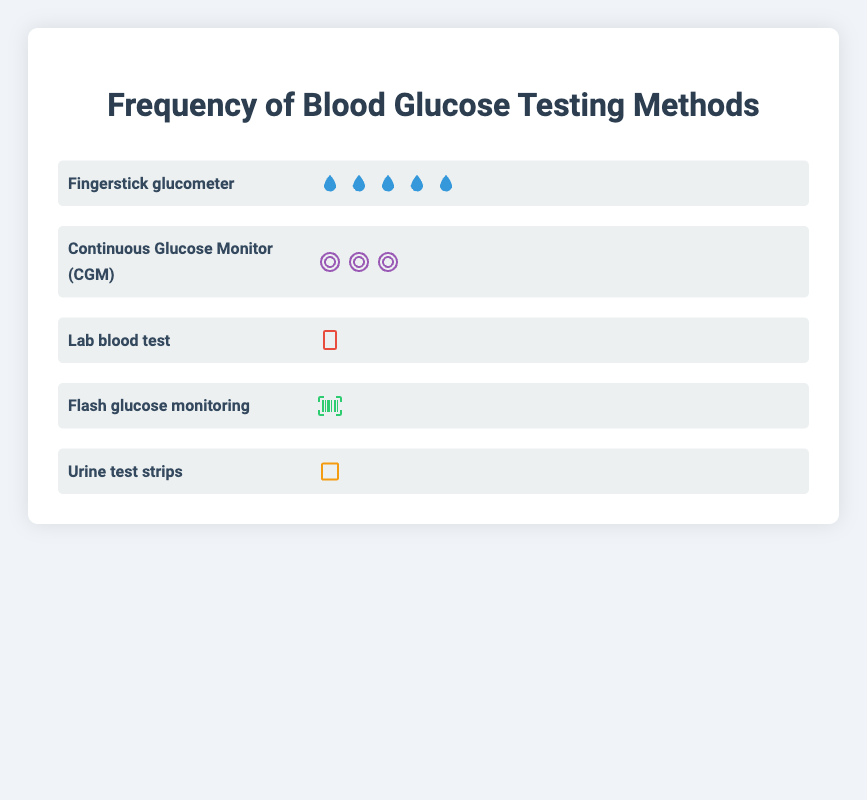What's the most frequently used blood glucose testing method? The "Fingerstick glucometer" method has the most icons (5), indicating it is the most commonly used method.
Answer: Fingerstick glucometer Which testing method is used the least frequently? The "Urine test strips" method has only one icon, indicating it is the least commonly used method.
Answer: Urine test strips How many more people use the Fingerstick glucometer compared to the Continuous Glucose Monitor (CGM)? The Fingerstick glucometer has 5 icons, while the CGM has 3 icons. The difference is 5 - 3 = 2.
Answer: 2 What percentage of people use Flash glucose monitoring? Flash glucose monitoring has 1 icon out of the total of 12 icons shown in the plot. The percentage is (1/12) * 100 ≈ 8.3%.
Answer: 8.3% Which testing methods have more than one icon? Methods with more than one icon are "Fingerstick glucometer" (5 icons), and "Continuous Glucose Monitor (CGM)" (3 icons).
Answer: Fingerstick glucometer, Continuous Glucose Monitor (CGM) How does the use of Lab blood tests compare to Flash glucose monitoring? Both Lab blood tests and Flash glucose monitoring each have 1 icon, indicating they are equally used.
Answer: Equal What's the combined frequency of Fingerstick glucometer and Continuous Glucose Monitor (CGM)? Fingerstick glucometer has 5 icons and CGM has 3 icons, making the combined total 5 + 3 = 8.
Answer: 8 Arrange the testing methods in descending order of usage. By counting the icons, the order from most to least used is: Fingerstick glucometer (5 icons), Continuous Glucose Monitor (CGM) (3 icons), Lab blood test (1 icon), Flash glucose monitoring (1 icon), Urine test strips (1 icon).
Answer: Fingerstick glucometer, Continuous Glucose Monitor (CGM), Lab blood test, Flash glucose monitoring, Urine test strips If a single icon represents 10 users, how many people use the Lab blood test? The Lab blood test has 1 icon. If one icon represents 10 users, the number of users is 1 * 10 = 10.
Answer: 10 